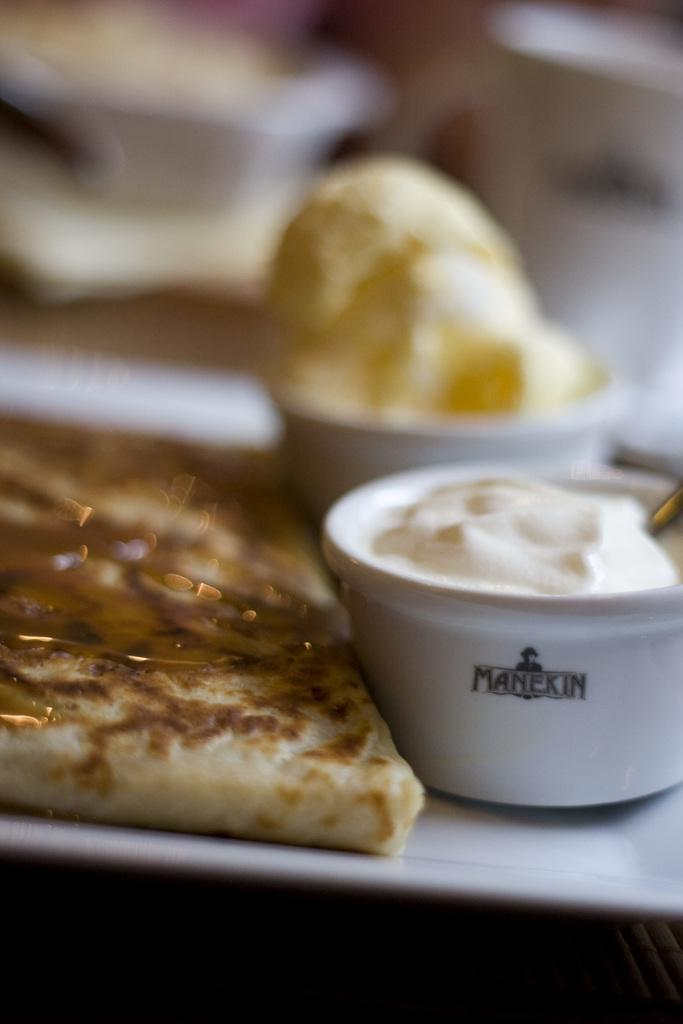What is the main object in the center of the image? There is a tray in the center of the image. What is placed on the tray? There is bread on the tray, and there are other food items in bowls on the tray. How many women are present in the image? There are no women present in the image; it only features a tray with food items. What type of cattle can be seen grazing in the background of the image? There is no background or cattle present in the image; it only features a tray with food items. 